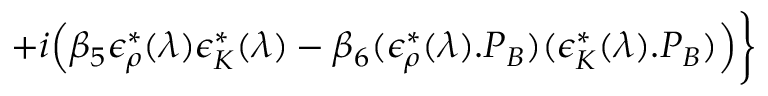Convert formula to latex. <formula><loc_0><loc_0><loc_500><loc_500>+ i \Big ( \beta _ { 5 } \epsilon _ { \rho } ^ { * } ( \lambda ) \epsilon _ { K } ^ { * } ( \lambda ) - \beta _ { 6 } ( \epsilon _ { \rho } ^ { * } ( \lambda ) . P _ { B } ) ( \epsilon _ { K } ^ { * } ( \lambda ) . P _ { B } ) \Big ) \Big \}</formula> 